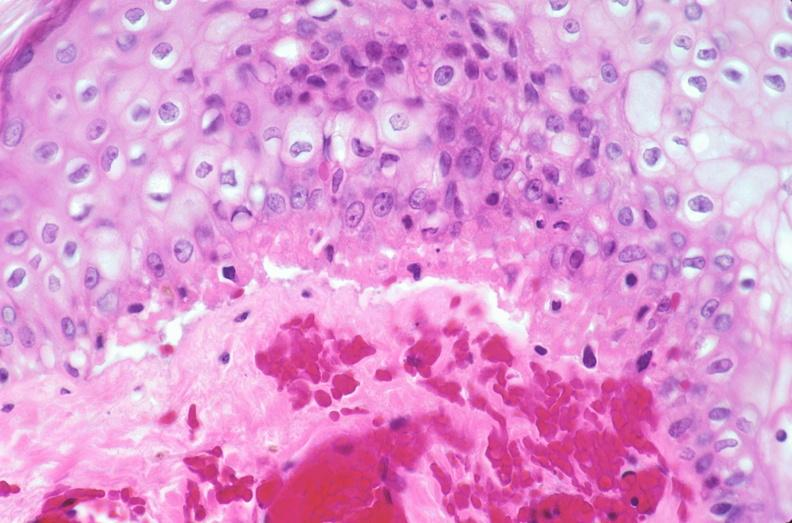what does this image show?
Answer the question using a single word or phrase. Skin 